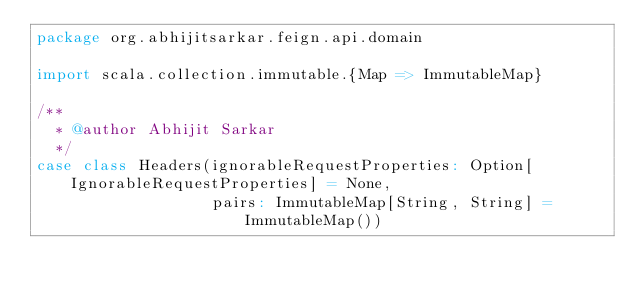<code> <loc_0><loc_0><loc_500><loc_500><_Scala_>package org.abhijitsarkar.feign.api.domain

import scala.collection.immutable.{Map => ImmutableMap}

/**
  * @author Abhijit Sarkar
  */
case class Headers(ignorableRequestProperties: Option[IgnorableRequestProperties] = None,
                   pairs: ImmutableMap[String, String] = ImmutableMap())


</code> 